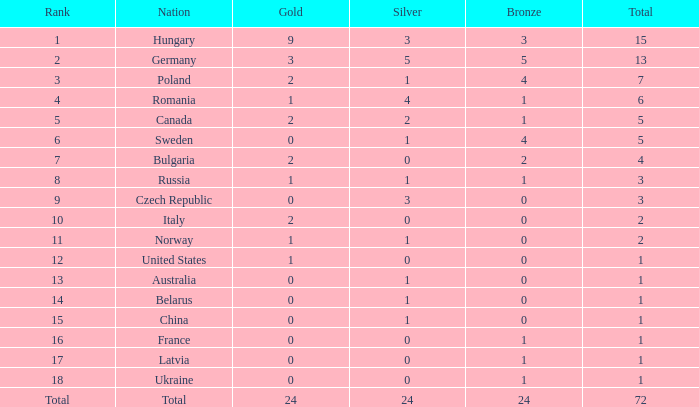What quantity of golds possess a 3 rank and a total surpassing 7? 0.0. 